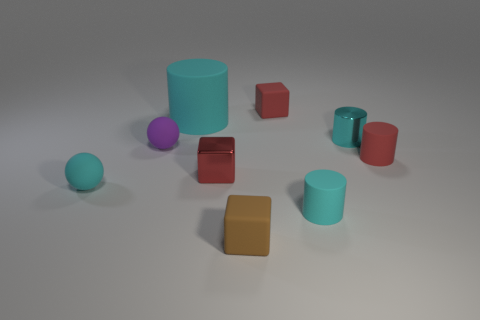How many cyan cylinders must be subtracted to get 1 cyan cylinders? 2 Subtract all green blocks. How many cyan cylinders are left? 3 Add 1 rubber balls. How many objects exist? 10 Subtract all spheres. How many objects are left? 7 Add 6 tiny purple rubber things. How many tiny purple rubber things exist? 7 Subtract 0 gray cylinders. How many objects are left? 9 Subtract all tiny cubes. Subtract all tiny shiny cylinders. How many objects are left? 5 Add 5 large cyan rubber objects. How many large cyan rubber objects are left? 6 